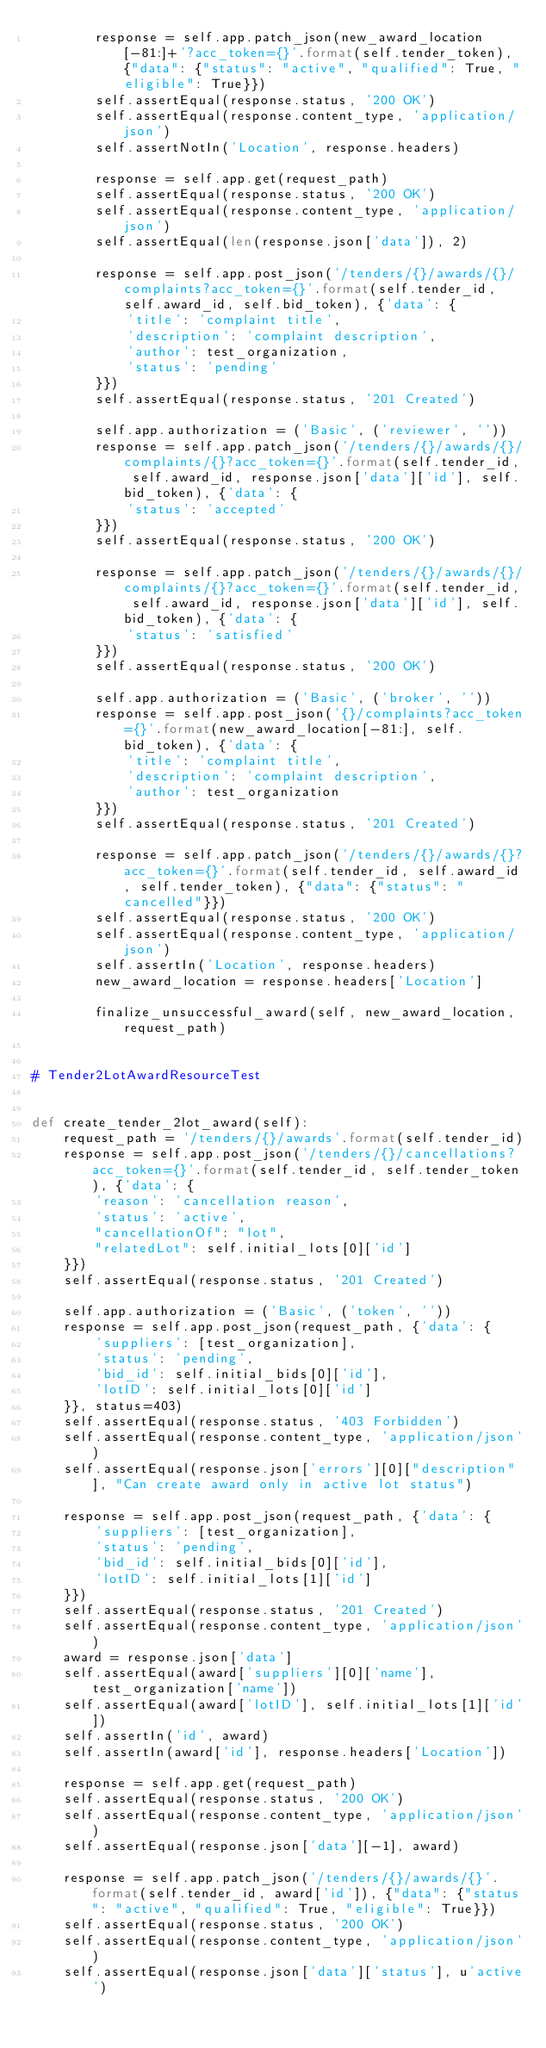Convert code to text. <code><loc_0><loc_0><loc_500><loc_500><_Python_>        response = self.app.patch_json(new_award_location[-81:]+'?acc_token={}'.format(self.tender_token), {"data": {"status": "active", "qualified": True, "eligible": True}})
        self.assertEqual(response.status, '200 OK')
        self.assertEqual(response.content_type, 'application/json')
        self.assertNotIn('Location', response.headers)

        response = self.app.get(request_path)
        self.assertEqual(response.status, '200 OK')
        self.assertEqual(response.content_type, 'application/json')
        self.assertEqual(len(response.json['data']), 2)

        response = self.app.post_json('/tenders/{}/awards/{}/complaints?acc_token={}'.format(self.tender_id, self.award_id, self.bid_token), {'data': {
            'title': 'complaint title',
            'description': 'complaint description',
            'author': test_organization,
            'status': 'pending'
        }})
        self.assertEqual(response.status, '201 Created')

        self.app.authorization = ('Basic', ('reviewer', ''))
        response = self.app.patch_json('/tenders/{}/awards/{}/complaints/{}?acc_token={}'.format(self.tender_id, self.award_id, response.json['data']['id'], self.bid_token), {'data': {
            'status': 'accepted'
        }})
        self.assertEqual(response.status, '200 OK')

        response = self.app.patch_json('/tenders/{}/awards/{}/complaints/{}?acc_token={}'.format(self.tender_id, self.award_id, response.json['data']['id'], self.bid_token), {'data': {
            'status': 'satisfied'
        }})
        self.assertEqual(response.status, '200 OK')

        self.app.authorization = ('Basic', ('broker', ''))
        response = self.app.post_json('{}/complaints?acc_token={}'.format(new_award_location[-81:], self.bid_token), {'data': {
            'title': 'complaint title',
            'description': 'complaint description',
            'author': test_organization
        }})
        self.assertEqual(response.status, '201 Created')

        response = self.app.patch_json('/tenders/{}/awards/{}?acc_token={}'.format(self.tender_id, self.award_id, self.tender_token), {"data": {"status": "cancelled"}})
        self.assertEqual(response.status, '200 OK')
        self.assertEqual(response.content_type, 'application/json')
        self.assertIn('Location', response.headers)
        new_award_location = response.headers['Location']

        finalize_unsuccessful_award(self, new_award_location, request_path)


# Tender2LotAwardResourceTest


def create_tender_2lot_award(self):
    request_path = '/tenders/{}/awards'.format(self.tender_id)
    response = self.app.post_json('/tenders/{}/cancellations?acc_token={}'.format(self.tender_id, self.tender_token), {'data': {
        'reason': 'cancellation reason',
        'status': 'active',
        "cancellationOf": "lot",
        "relatedLot": self.initial_lots[0]['id']
    }})
    self.assertEqual(response.status, '201 Created')

    self.app.authorization = ('Basic', ('token', ''))
    response = self.app.post_json(request_path, {'data': {
        'suppliers': [test_organization],
        'status': 'pending',
        'bid_id': self.initial_bids[0]['id'],
        'lotID': self.initial_lots[0]['id']
    }}, status=403)
    self.assertEqual(response.status, '403 Forbidden')
    self.assertEqual(response.content_type, 'application/json')
    self.assertEqual(response.json['errors'][0]["description"], "Can create award only in active lot status")

    response = self.app.post_json(request_path, {'data': {
        'suppliers': [test_organization],
        'status': 'pending',
        'bid_id': self.initial_bids[0]['id'],
        'lotID': self.initial_lots[1]['id']
    }})
    self.assertEqual(response.status, '201 Created')
    self.assertEqual(response.content_type, 'application/json')
    award = response.json['data']
    self.assertEqual(award['suppliers'][0]['name'], test_organization['name'])
    self.assertEqual(award['lotID'], self.initial_lots[1]['id'])
    self.assertIn('id', award)
    self.assertIn(award['id'], response.headers['Location'])

    response = self.app.get(request_path)
    self.assertEqual(response.status, '200 OK')
    self.assertEqual(response.content_type, 'application/json')
    self.assertEqual(response.json['data'][-1], award)

    response = self.app.patch_json('/tenders/{}/awards/{}'.format(self.tender_id, award['id']), {"data": {"status": "active", "qualified": True, "eligible": True}})
    self.assertEqual(response.status, '200 OK')
    self.assertEqual(response.content_type, 'application/json')
    self.assertEqual(response.json['data']['status'], u'active')
</code> 